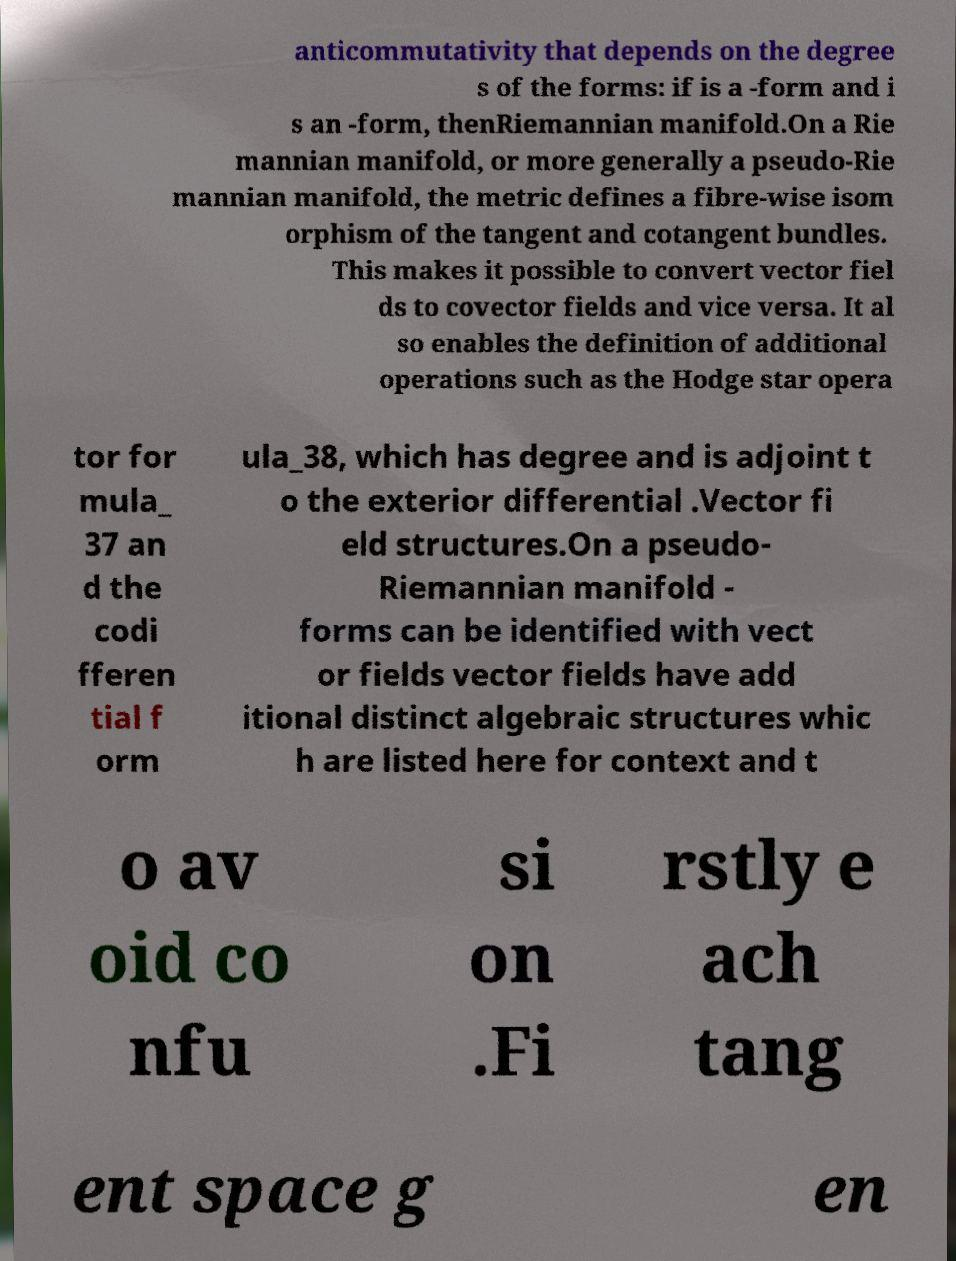There's text embedded in this image that I need extracted. Can you transcribe it verbatim? anticommutativity that depends on the degree s of the forms: if is a -form and i s an -form, thenRiemannian manifold.On a Rie mannian manifold, or more generally a pseudo-Rie mannian manifold, the metric defines a fibre-wise isom orphism of the tangent and cotangent bundles. This makes it possible to convert vector fiel ds to covector fields and vice versa. It al so enables the definition of additional operations such as the Hodge star opera tor for mula_ 37 an d the codi fferen tial f orm ula_38, which has degree and is adjoint t o the exterior differential .Vector fi eld structures.On a pseudo- Riemannian manifold - forms can be identified with vect or fields vector fields have add itional distinct algebraic structures whic h are listed here for context and t o av oid co nfu si on .Fi rstly e ach tang ent space g en 